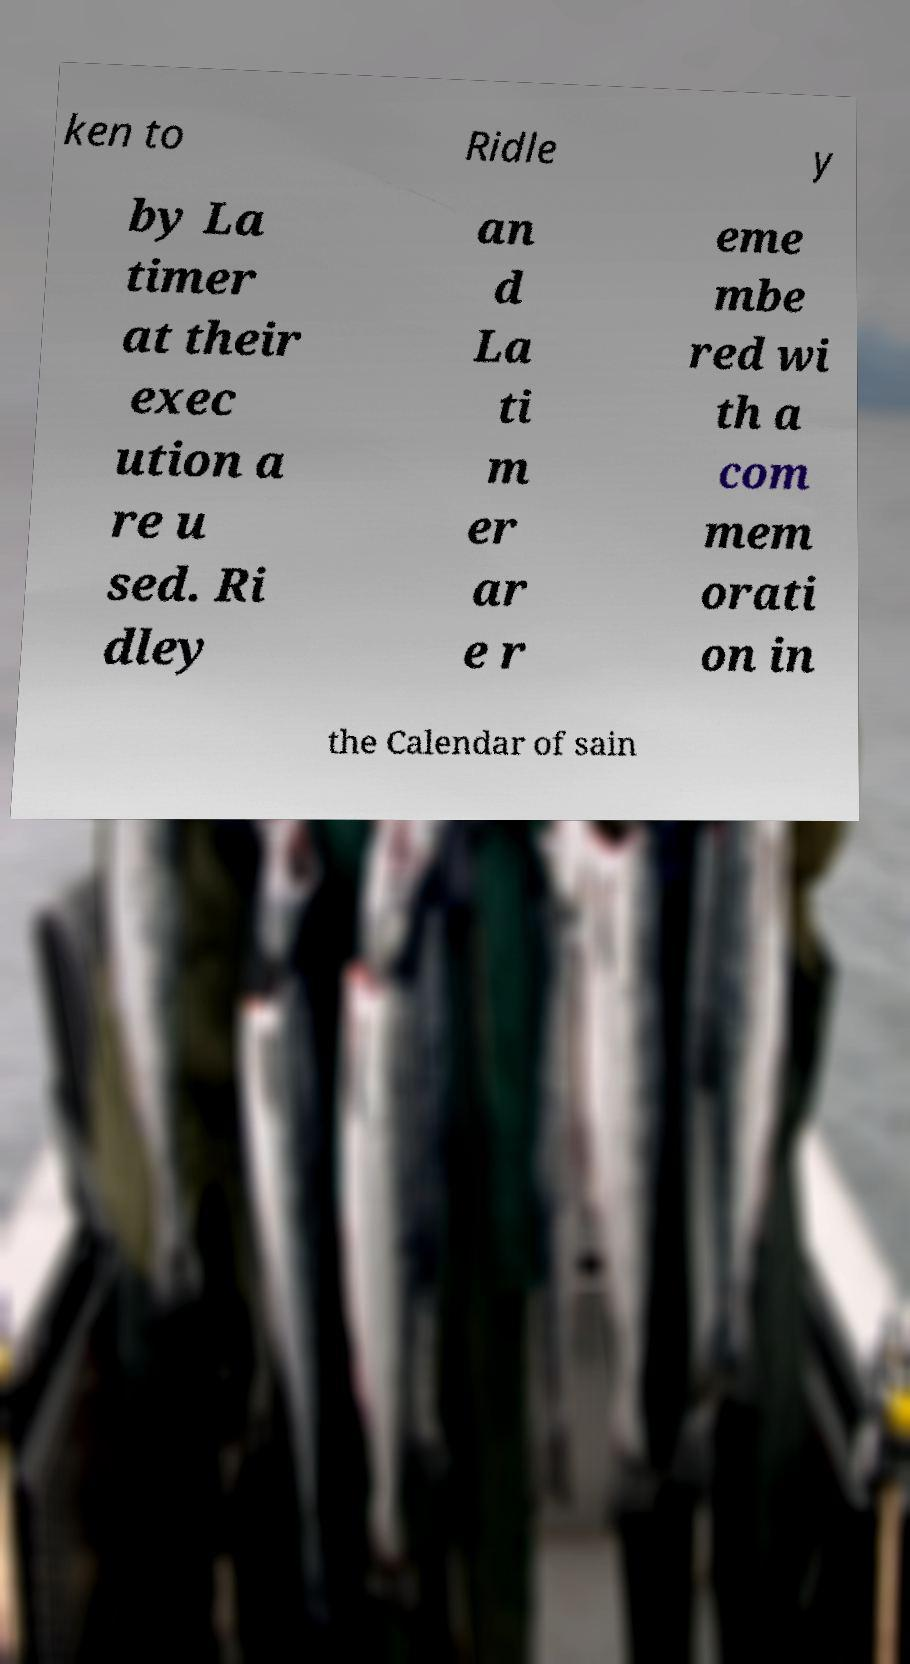Can you accurately transcribe the text from the provided image for me? ken to Ridle y by La timer at their exec ution a re u sed. Ri dley an d La ti m er ar e r eme mbe red wi th a com mem orati on in the Calendar of sain 